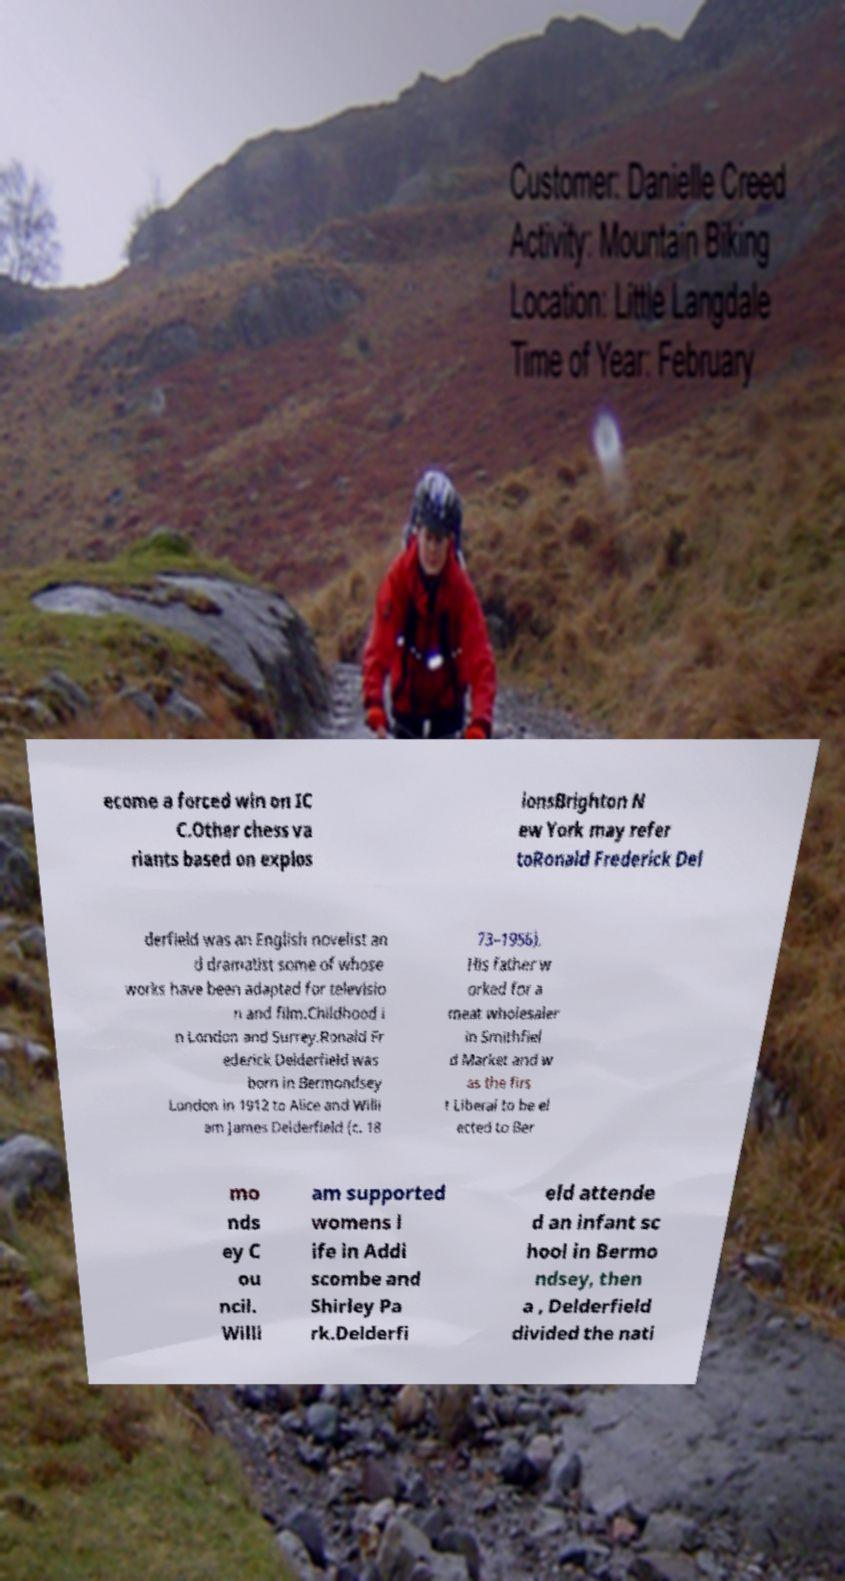For documentation purposes, I need the text within this image transcribed. Could you provide that? ecome a forced win on IC C.Other chess va riants based on explos ionsBrighton N ew York may refer toRonald Frederick Del derfield was an English novelist an d dramatist some of whose works have been adapted for televisio n and film.Childhood i n London and Surrey.Ronald Fr ederick Delderfield was born in Bermondsey London in 1912 to Alice and Willi am James Delderfield (c. 18 73–1956). His father w orked for a meat wholesaler in Smithfiel d Market and w as the firs t Liberal to be el ected to Ber mo nds ey C ou ncil. Willi am supported womens l ife in Addi scombe and Shirley Pa rk.Delderfi eld attende d an infant sc hool in Bermo ndsey, then a , Delderfield divided the nati 